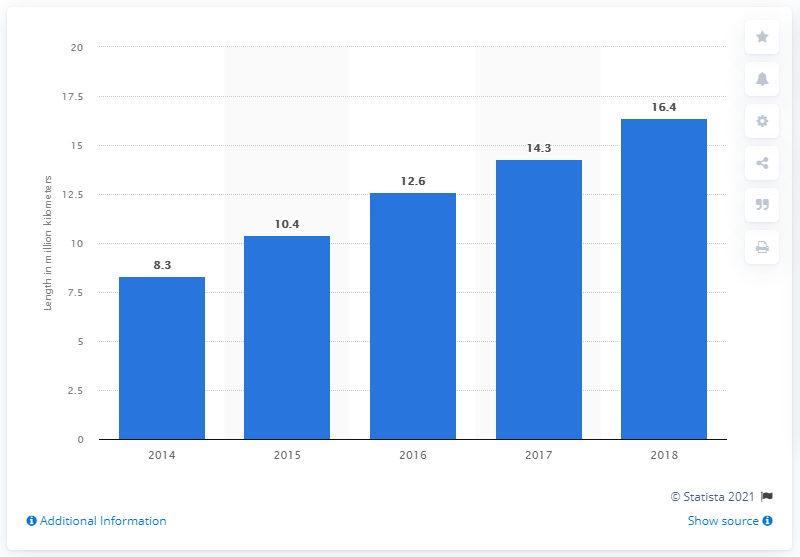Point out several critical features in this image. In 2014, the network was approximately 8.3... In 2018, the length of the network was 16.4 kilometers. 